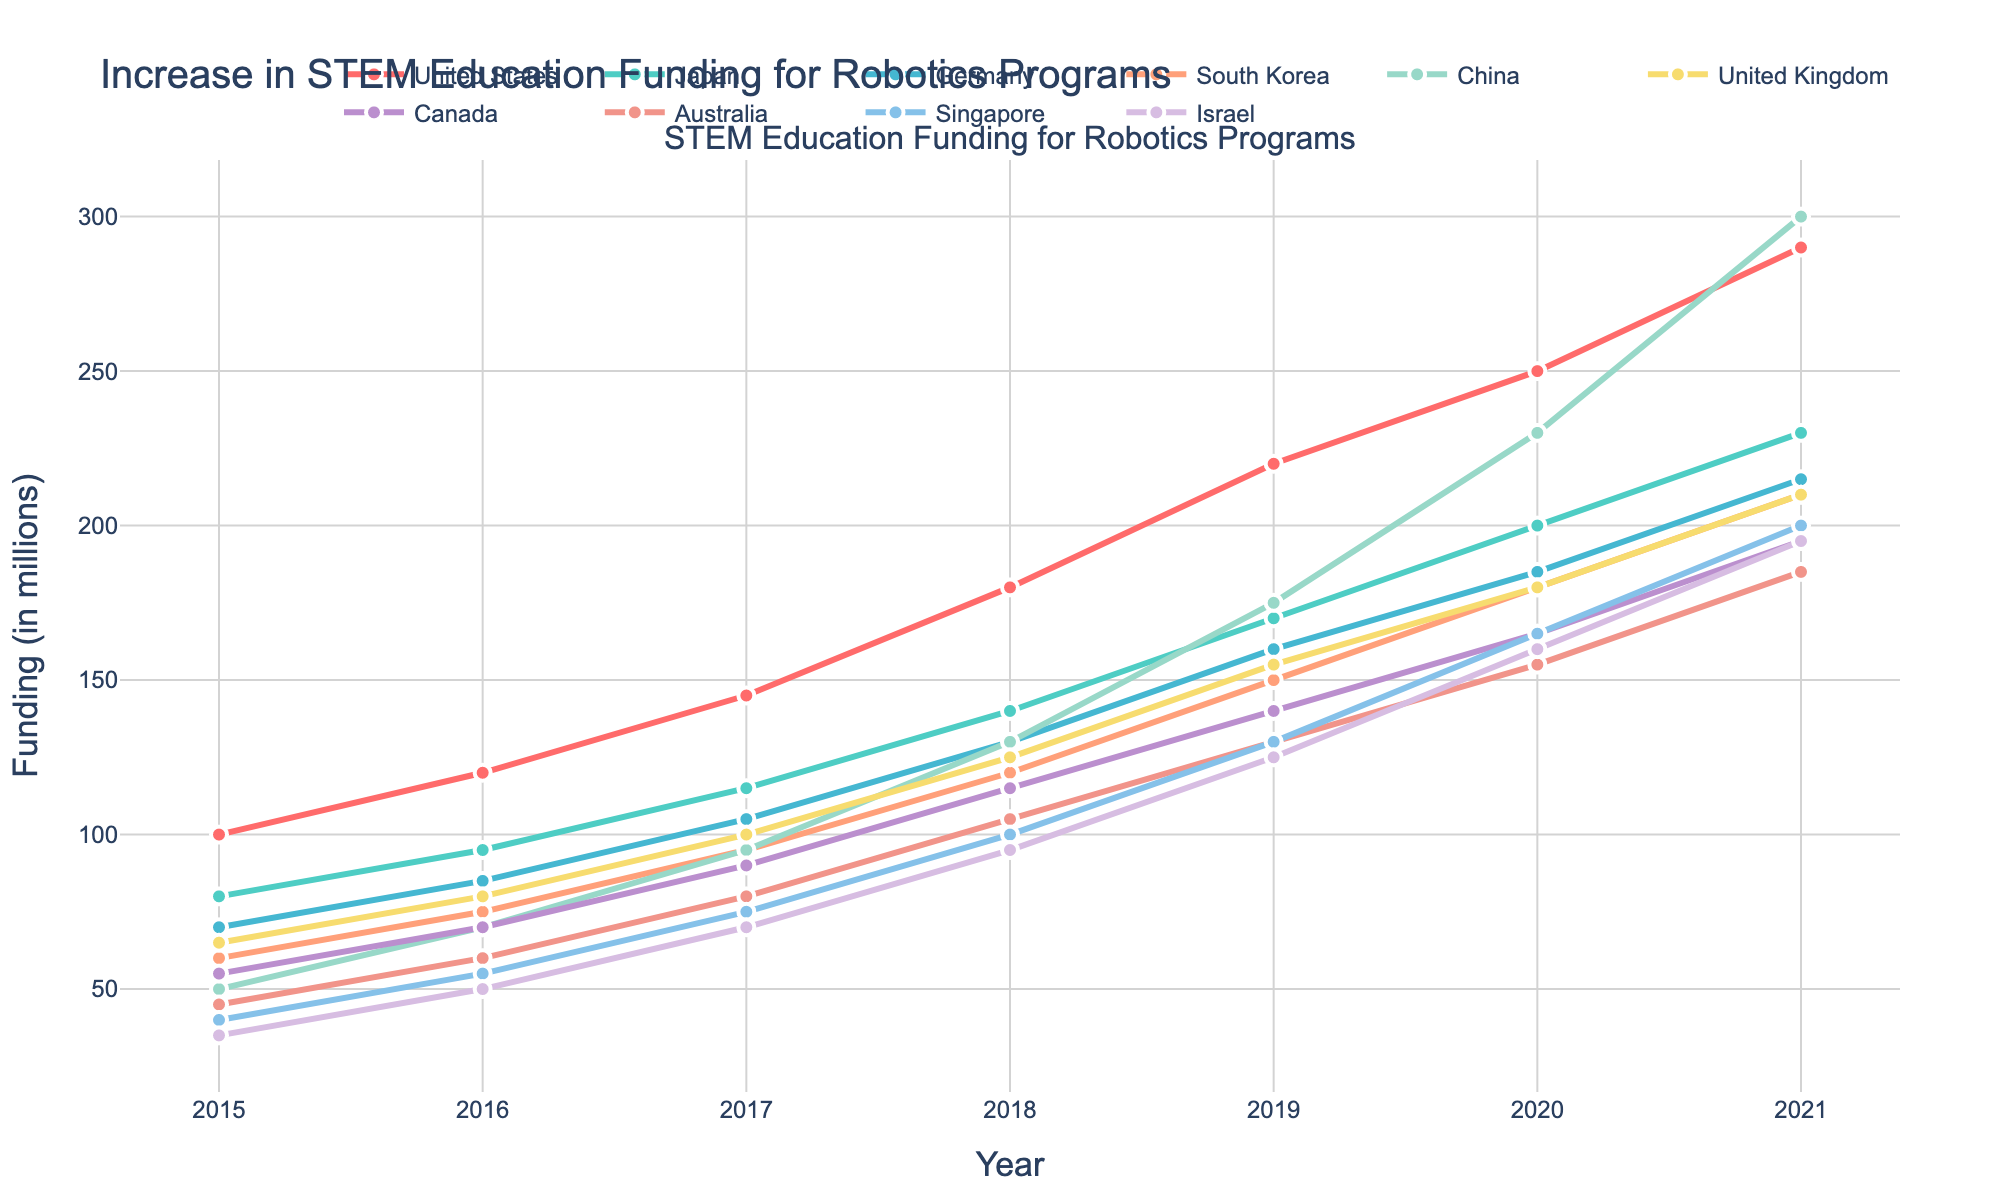What was the total funding increase for China from 2015 to 2021? First, find the funding in 2015 for China, which is 50 million. Then find the funding in 2021 for China, which is 300 million. Subtract the 2015 funding from the 2021 funding (300 - 50).
Answer: 250 million Which country had the highest funding in 2021? Look at the funding values for all countries in 2021. China has the highest value, which is 300 million.
Answer: China Did Israel ever have higher funding than Australia in any year? Compare the funding for Israel and Australia year by year. Israel's funding was never higher than Australia's funding in any given year.
Answer: No Between 2018 and 2019, which country saw the largest increase in funding? Calculate the difference in funding between 2018 and 2019 for each country. China had the largest increase (175 - 130 = 45 million).
Answer: China What is the average funding in 2020 across all countries? Add all the 2020 funding values: (250 + 200 + 185 + 180 + 230 + 180 + 165 + 155 + 165 + 160) = 1870 million, then divide by the number of countries (10). 1870 / 10 = 187 million.
Answer: 187 million In which year did Japan's funding surpass Germany's funding? Compare Japan and Germany's funding year by year. In 2017, Japan's funding (115 million) surpassed Germany's funding (105 million).
Answer: 2017 Which country experienced the smallest growth from 2015 to 2021? Calculate the difference in funding from 2015 to 2021 for each country. Australia saw the smallest growth (185 - 45 = 140 million).
Answer: Australia Which countries had more than 200 million in funding in 2020? Identify the countries with funding values greater than 200 million in 2020. The United States and China had more than 200 million.
Answer: United States, China Which country had the most consistent increase in funding from 2015 to 2021? Look for the country with steady increases each year. The United States shows a consistent increase each year from 2015 to 2021.
Answer: United States How many countries had their funding doubled from 2015 to 2021? Calculate the funding for 2021 and compare it to the funding in 2015 to see if it at least doubled. The United States (290 > 2*100), Japan (230 > 2*80), South Korea (210 > 2*60), China (300 > 2*50), United Kingdom (210 > 2*65), Singapore (200 > 2*40), and Israel (195 > 2*35) all doubled their funding.
Answer: 7 